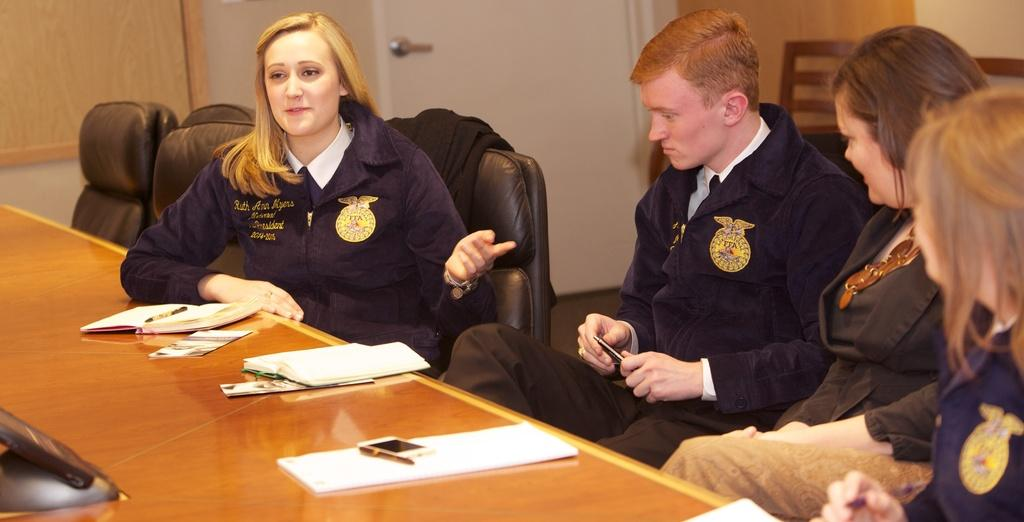What are the people in the image doing? The people are sitting in the foreground of the image. What is in front of the people? The people are sitting in front of a table. What items can be seen on the table? There are papers, pens, and a phone on the table. What can be seen in the background of the image? It appears to be a bench in the background, and there is a door in the background. What type of alarm is ringing in the image? There is no alarm ringing in the image; it is not mentioned in the provided facts. Can you see an ant crawling on the table in the image? There is no ant present in the image; it is not mentioned in the provided facts. 